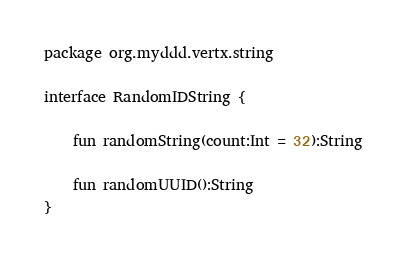<code> <loc_0><loc_0><loc_500><loc_500><_Kotlin_>package org.myddd.vertx.string

interface RandomIDString {

    fun randomString(count:Int = 32):String

    fun randomUUID():String
}</code> 